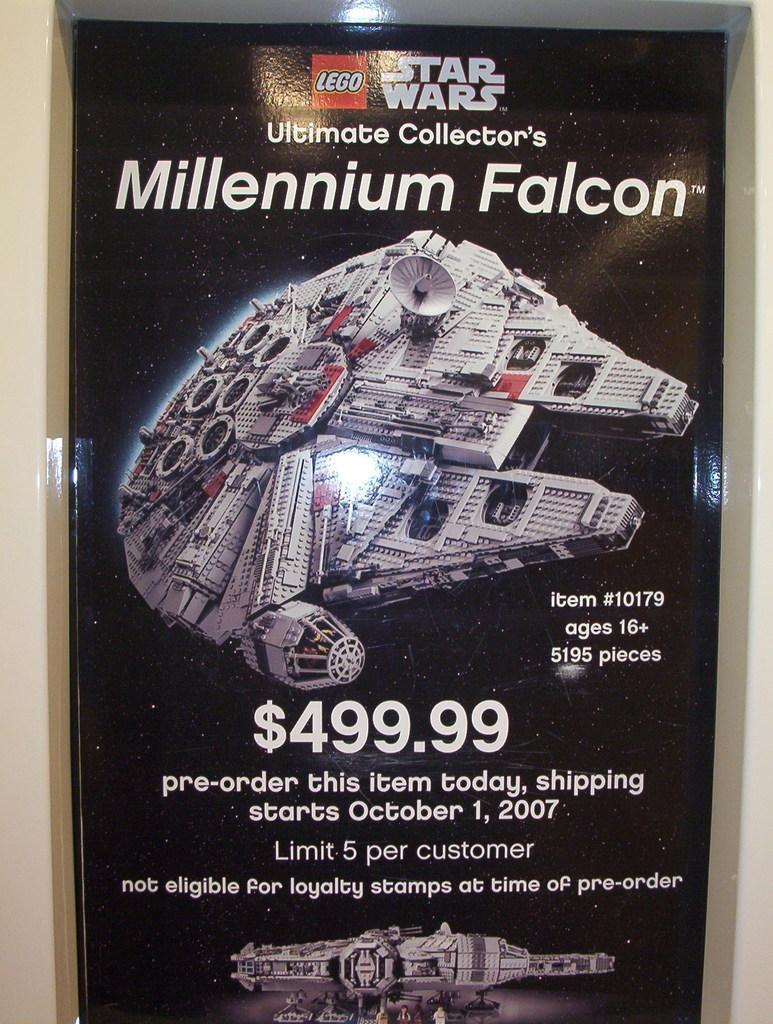<image>
Give a short and clear explanation of the subsequent image. Lego Star Wars poster for the Millennium Falcon. 